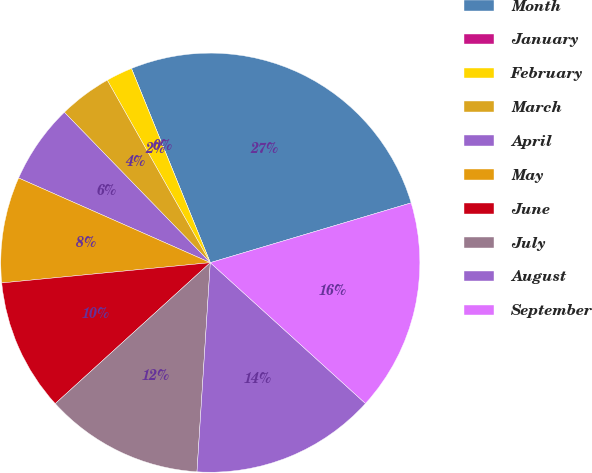<chart> <loc_0><loc_0><loc_500><loc_500><pie_chart><fcel>Month<fcel>January<fcel>February<fcel>March<fcel>April<fcel>May<fcel>June<fcel>July<fcel>August<fcel>September<nl><fcel>26.53%<fcel>0.0%<fcel>2.04%<fcel>4.08%<fcel>6.12%<fcel>8.16%<fcel>10.2%<fcel>12.24%<fcel>14.28%<fcel>16.33%<nl></chart> 